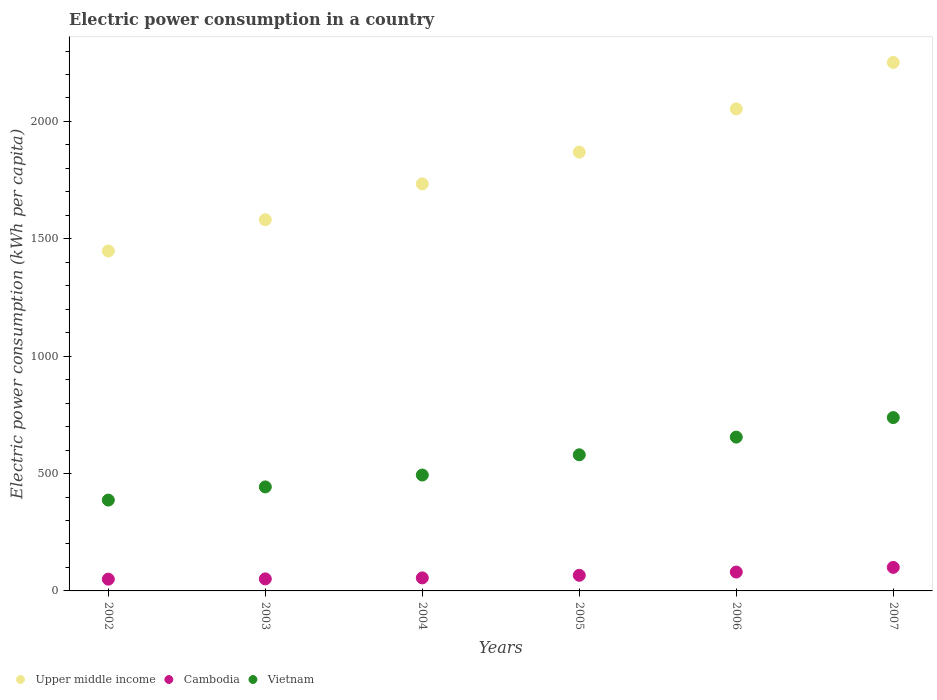How many different coloured dotlines are there?
Your answer should be compact. 3. What is the electric power consumption in in Cambodia in 2006?
Keep it short and to the point. 80.44. Across all years, what is the maximum electric power consumption in in Cambodia?
Offer a very short reply. 100.23. Across all years, what is the minimum electric power consumption in in Cambodia?
Your answer should be very brief. 50.15. In which year was the electric power consumption in in Vietnam maximum?
Provide a succinct answer. 2007. What is the total electric power consumption in in Cambodia in the graph?
Keep it short and to the point. 404.17. What is the difference between the electric power consumption in in Vietnam in 2003 and that in 2006?
Offer a very short reply. -212.25. What is the difference between the electric power consumption in in Cambodia in 2002 and the electric power consumption in in Upper middle income in 2005?
Ensure brevity in your answer.  -1819.17. What is the average electric power consumption in in Cambodia per year?
Offer a terse response. 67.36. In the year 2006, what is the difference between the electric power consumption in in Cambodia and electric power consumption in in Vietnam?
Ensure brevity in your answer.  -574.88. In how many years, is the electric power consumption in in Cambodia greater than 500 kWh per capita?
Make the answer very short. 0. What is the ratio of the electric power consumption in in Vietnam in 2005 to that in 2007?
Keep it short and to the point. 0.79. What is the difference between the highest and the second highest electric power consumption in in Vietnam?
Your answer should be compact. 83.15. What is the difference between the highest and the lowest electric power consumption in in Upper middle income?
Your response must be concise. 803.33. Is the sum of the electric power consumption in in Upper middle income in 2003 and 2004 greater than the maximum electric power consumption in in Cambodia across all years?
Give a very brief answer. Yes. Is it the case that in every year, the sum of the electric power consumption in in Upper middle income and electric power consumption in in Vietnam  is greater than the electric power consumption in in Cambodia?
Offer a very short reply. Yes. Is the electric power consumption in in Upper middle income strictly greater than the electric power consumption in in Cambodia over the years?
Offer a very short reply. Yes. How many years are there in the graph?
Your answer should be compact. 6. What is the difference between two consecutive major ticks on the Y-axis?
Provide a succinct answer. 500. Where does the legend appear in the graph?
Your response must be concise. Bottom left. How many legend labels are there?
Provide a succinct answer. 3. What is the title of the graph?
Keep it short and to the point. Electric power consumption in a country. Does "Moldova" appear as one of the legend labels in the graph?
Your answer should be very brief. No. What is the label or title of the X-axis?
Make the answer very short. Years. What is the label or title of the Y-axis?
Ensure brevity in your answer.  Electric power consumption (kWh per capita). What is the Electric power consumption (kWh per capita) in Upper middle income in 2002?
Ensure brevity in your answer.  1448.2. What is the Electric power consumption (kWh per capita) of Cambodia in 2002?
Your answer should be compact. 50.15. What is the Electric power consumption (kWh per capita) of Vietnam in 2002?
Your answer should be very brief. 387.04. What is the Electric power consumption (kWh per capita) in Upper middle income in 2003?
Make the answer very short. 1581.37. What is the Electric power consumption (kWh per capita) in Cambodia in 2003?
Provide a short and direct response. 51.31. What is the Electric power consumption (kWh per capita) in Vietnam in 2003?
Provide a succinct answer. 443.07. What is the Electric power consumption (kWh per capita) of Upper middle income in 2004?
Your answer should be very brief. 1734. What is the Electric power consumption (kWh per capita) of Cambodia in 2004?
Provide a succinct answer. 55.52. What is the Electric power consumption (kWh per capita) of Vietnam in 2004?
Provide a short and direct response. 493.62. What is the Electric power consumption (kWh per capita) in Upper middle income in 2005?
Your answer should be very brief. 1869.32. What is the Electric power consumption (kWh per capita) in Cambodia in 2005?
Provide a succinct answer. 66.52. What is the Electric power consumption (kWh per capita) in Vietnam in 2005?
Offer a very short reply. 579.92. What is the Electric power consumption (kWh per capita) in Upper middle income in 2006?
Provide a short and direct response. 2053.57. What is the Electric power consumption (kWh per capita) in Cambodia in 2006?
Your answer should be compact. 80.44. What is the Electric power consumption (kWh per capita) in Vietnam in 2006?
Provide a succinct answer. 655.33. What is the Electric power consumption (kWh per capita) in Upper middle income in 2007?
Your response must be concise. 2251.53. What is the Electric power consumption (kWh per capita) in Cambodia in 2007?
Provide a succinct answer. 100.23. What is the Electric power consumption (kWh per capita) in Vietnam in 2007?
Offer a terse response. 738.47. Across all years, what is the maximum Electric power consumption (kWh per capita) in Upper middle income?
Give a very brief answer. 2251.53. Across all years, what is the maximum Electric power consumption (kWh per capita) of Cambodia?
Provide a succinct answer. 100.23. Across all years, what is the maximum Electric power consumption (kWh per capita) in Vietnam?
Your answer should be compact. 738.47. Across all years, what is the minimum Electric power consumption (kWh per capita) of Upper middle income?
Offer a very short reply. 1448.2. Across all years, what is the minimum Electric power consumption (kWh per capita) in Cambodia?
Your response must be concise. 50.15. Across all years, what is the minimum Electric power consumption (kWh per capita) of Vietnam?
Your response must be concise. 387.04. What is the total Electric power consumption (kWh per capita) of Upper middle income in the graph?
Your answer should be compact. 1.09e+04. What is the total Electric power consumption (kWh per capita) of Cambodia in the graph?
Ensure brevity in your answer.  404.17. What is the total Electric power consumption (kWh per capita) of Vietnam in the graph?
Give a very brief answer. 3297.45. What is the difference between the Electric power consumption (kWh per capita) of Upper middle income in 2002 and that in 2003?
Your answer should be very brief. -133.17. What is the difference between the Electric power consumption (kWh per capita) in Cambodia in 2002 and that in 2003?
Your answer should be compact. -1.16. What is the difference between the Electric power consumption (kWh per capita) in Vietnam in 2002 and that in 2003?
Provide a succinct answer. -56.04. What is the difference between the Electric power consumption (kWh per capita) of Upper middle income in 2002 and that in 2004?
Your response must be concise. -285.8. What is the difference between the Electric power consumption (kWh per capita) of Cambodia in 2002 and that in 2004?
Your answer should be compact. -5.37. What is the difference between the Electric power consumption (kWh per capita) in Vietnam in 2002 and that in 2004?
Give a very brief answer. -106.59. What is the difference between the Electric power consumption (kWh per capita) of Upper middle income in 2002 and that in 2005?
Provide a short and direct response. -421.12. What is the difference between the Electric power consumption (kWh per capita) in Cambodia in 2002 and that in 2005?
Ensure brevity in your answer.  -16.37. What is the difference between the Electric power consumption (kWh per capita) of Vietnam in 2002 and that in 2005?
Keep it short and to the point. -192.89. What is the difference between the Electric power consumption (kWh per capita) of Upper middle income in 2002 and that in 2006?
Keep it short and to the point. -605.37. What is the difference between the Electric power consumption (kWh per capita) in Cambodia in 2002 and that in 2006?
Make the answer very short. -30.29. What is the difference between the Electric power consumption (kWh per capita) in Vietnam in 2002 and that in 2006?
Offer a very short reply. -268.29. What is the difference between the Electric power consumption (kWh per capita) of Upper middle income in 2002 and that in 2007?
Offer a very short reply. -803.33. What is the difference between the Electric power consumption (kWh per capita) in Cambodia in 2002 and that in 2007?
Provide a succinct answer. -50.08. What is the difference between the Electric power consumption (kWh per capita) in Vietnam in 2002 and that in 2007?
Your response must be concise. -351.44. What is the difference between the Electric power consumption (kWh per capita) of Upper middle income in 2003 and that in 2004?
Make the answer very short. -152.64. What is the difference between the Electric power consumption (kWh per capita) of Cambodia in 2003 and that in 2004?
Give a very brief answer. -4.21. What is the difference between the Electric power consumption (kWh per capita) of Vietnam in 2003 and that in 2004?
Offer a very short reply. -50.55. What is the difference between the Electric power consumption (kWh per capita) of Upper middle income in 2003 and that in 2005?
Make the answer very short. -287.95. What is the difference between the Electric power consumption (kWh per capita) of Cambodia in 2003 and that in 2005?
Your answer should be very brief. -15.2. What is the difference between the Electric power consumption (kWh per capita) in Vietnam in 2003 and that in 2005?
Your response must be concise. -136.85. What is the difference between the Electric power consumption (kWh per capita) in Upper middle income in 2003 and that in 2006?
Offer a terse response. -472.2. What is the difference between the Electric power consumption (kWh per capita) of Cambodia in 2003 and that in 2006?
Offer a terse response. -29.13. What is the difference between the Electric power consumption (kWh per capita) of Vietnam in 2003 and that in 2006?
Your response must be concise. -212.25. What is the difference between the Electric power consumption (kWh per capita) of Upper middle income in 2003 and that in 2007?
Offer a very short reply. -670.17. What is the difference between the Electric power consumption (kWh per capita) of Cambodia in 2003 and that in 2007?
Give a very brief answer. -48.91. What is the difference between the Electric power consumption (kWh per capita) of Vietnam in 2003 and that in 2007?
Your response must be concise. -295.4. What is the difference between the Electric power consumption (kWh per capita) in Upper middle income in 2004 and that in 2005?
Your response must be concise. -135.32. What is the difference between the Electric power consumption (kWh per capita) of Cambodia in 2004 and that in 2005?
Make the answer very short. -11. What is the difference between the Electric power consumption (kWh per capita) of Vietnam in 2004 and that in 2005?
Provide a short and direct response. -86.3. What is the difference between the Electric power consumption (kWh per capita) in Upper middle income in 2004 and that in 2006?
Make the answer very short. -319.56. What is the difference between the Electric power consumption (kWh per capita) in Cambodia in 2004 and that in 2006?
Keep it short and to the point. -24.92. What is the difference between the Electric power consumption (kWh per capita) of Vietnam in 2004 and that in 2006?
Keep it short and to the point. -161.7. What is the difference between the Electric power consumption (kWh per capita) in Upper middle income in 2004 and that in 2007?
Offer a terse response. -517.53. What is the difference between the Electric power consumption (kWh per capita) of Cambodia in 2004 and that in 2007?
Provide a succinct answer. -44.71. What is the difference between the Electric power consumption (kWh per capita) of Vietnam in 2004 and that in 2007?
Provide a short and direct response. -244.85. What is the difference between the Electric power consumption (kWh per capita) of Upper middle income in 2005 and that in 2006?
Your response must be concise. -184.25. What is the difference between the Electric power consumption (kWh per capita) of Cambodia in 2005 and that in 2006?
Make the answer very short. -13.93. What is the difference between the Electric power consumption (kWh per capita) of Vietnam in 2005 and that in 2006?
Your response must be concise. -75.4. What is the difference between the Electric power consumption (kWh per capita) in Upper middle income in 2005 and that in 2007?
Your answer should be very brief. -382.21. What is the difference between the Electric power consumption (kWh per capita) in Cambodia in 2005 and that in 2007?
Ensure brevity in your answer.  -33.71. What is the difference between the Electric power consumption (kWh per capita) of Vietnam in 2005 and that in 2007?
Offer a terse response. -158.55. What is the difference between the Electric power consumption (kWh per capita) of Upper middle income in 2006 and that in 2007?
Offer a terse response. -197.97. What is the difference between the Electric power consumption (kWh per capita) of Cambodia in 2006 and that in 2007?
Ensure brevity in your answer.  -19.79. What is the difference between the Electric power consumption (kWh per capita) of Vietnam in 2006 and that in 2007?
Your response must be concise. -83.15. What is the difference between the Electric power consumption (kWh per capita) of Upper middle income in 2002 and the Electric power consumption (kWh per capita) of Cambodia in 2003?
Your answer should be compact. 1396.89. What is the difference between the Electric power consumption (kWh per capita) of Upper middle income in 2002 and the Electric power consumption (kWh per capita) of Vietnam in 2003?
Your answer should be very brief. 1005.13. What is the difference between the Electric power consumption (kWh per capita) of Cambodia in 2002 and the Electric power consumption (kWh per capita) of Vietnam in 2003?
Your answer should be compact. -392.92. What is the difference between the Electric power consumption (kWh per capita) in Upper middle income in 2002 and the Electric power consumption (kWh per capita) in Cambodia in 2004?
Ensure brevity in your answer.  1392.68. What is the difference between the Electric power consumption (kWh per capita) of Upper middle income in 2002 and the Electric power consumption (kWh per capita) of Vietnam in 2004?
Your answer should be compact. 954.58. What is the difference between the Electric power consumption (kWh per capita) in Cambodia in 2002 and the Electric power consumption (kWh per capita) in Vietnam in 2004?
Provide a succinct answer. -443.47. What is the difference between the Electric power consumption (kWh per capita) in Upper middle income in 2002 and the Electric power consumption (kWh per capita) in Cambodia in 2005?
Provide a succinct answer. 1381.68. What is the difference between the Electric power consumption (kWh per capita) of Upper middle income in 2002 and the Electric power consumption (kWh per capita) of Vietnam in 2005?
Your response must be concise. 868.28. What is the difference between the Electric power consumption (kWh per capita) of Cambodia in 2002 and the Electric power consumption (kWh per capita) of Vietnam in 2005?
Make the answer very short. -529.77. What is the difference between the Electric power consumption (kWh per capita) in Upper middle income in 2002 and the Electric power consumption (kWh per capita) in Cambodia in 2006?
Offer a very short reply. 1367.76. What is the difference between the Electric power consumption (kWh per capita) of Upper middle income in 2002 and the Electric power consumption (kWh per capita) of Vietnam in 2006?
Offer a very short reply. 792.87. What is the difference between the Electric power consumption (kWh per capita) of Cambodia in 2002 and the Electric power consumption (kWh per capita) of Vietnam in 2006?
Your response must be concise. -605.18. What is the difference between the Electric power consumption (kWh per capita) in Upper middle income in 2002 and the Electric power consumption (kWh per capita) in Cambodia in 2007?
Provide a short and direct response. 1347.97. What is the difference between the Electric power consumption (kWh per capita) of Upper middle income in 2002 and the Electric power consumption (kWh per capita) of Vietnam in 2007?
Give a very brief answer. 709.73. What is the difference between the Electric power consumption (kWh per capita) in Cambodia in 2002 and the Electric power consumption (kWh per capita) in Vietnam in 2007?
Offer a very short reply. -688.32. What is the difference between the Electric power consumption (kWh per capita) in Upper middle income in 2003 and the Electric power consumption (kWh per capita) in Cambodia in 2004?
Make the answer very short. 1525.85. What is the difference between the Electric power consumption (kWh per capita) of Upper middle income in 2003 and the Electric power consumption (kWh per capita) of Vietnam in 2004?
Your answer should be very brief. 1087.74. What is the difference between the Electric power consumption (kWh per capita) in Cambodia in 2003 and the Electric power consumption (kWh per capita) in Vietnam in 2004?
Offer a terse response. -442.31. What is the difference between the Electric power consumption (kWh per capita) in Upper middle income in 2003 and the Electric power consumption (kWh per capita) in Cambodia in 2005?
Keep it short and to the point. 1514.85. What is the difference between the Electric power consumption (kWh per capita) of Upper middle income in 2003 and the Electric power consumption (kWh per capita) of Vietnam in 2005?
Provide a short and direct response. 1001.45. What is the difference between the Electric power consumption (kWh per capita) in Cambodia in 2003 and the Electric power consumption (kWh per capita) in Vietnam in 2005?
Give a very brief answer. -528.61. What is the difference between the Electric power consumption (kWh per capita) of Upper middle income in 2003 and the Electric power consumption (kWh per capita) of Cambodia in 2006?
Provide a short and direct response. 1500.93. What is the difference between the Electric power consumption (kWh per capita) of Upper middle income in 2003 and the Electric power consumption (kWh per capita) of Vietnam in 2006?
Offer a very short reply. 926.04. What is the difference between the Electric power consumption (kWh per capita) of Cambodia in 2003 and the Electric power consumption (kWh per capita) of Vietnam in 2006?
Ensure brevity in your answer.  -604.01. What is the difference between the Electric power consumption (kWh per capita) in Upper middle income in 2003 and the Electric power consumption (kWh per capita) in Cambodia in 2007?
Your answer should be compact. 1481.14. What is the difference between the Electric power consumption (kWh per capita) of Upper middle income in 2003 and the Electric power consumption (kWh per capita) of Vietnam in 2007?
Your answer should be very brief. 842.9. What is the difference between the Electric power consumption (kWh per capita) of Cambodia in 2003 and the Electric power consumption (kWh per capita) of Vietnam in 2007?
Offer a very short reply. -687.16. What is the difference between the Electric power consumption (kWh per capita) in Upper middle income in 2004 and the Electric power consumption (kWh per capita) in Cambodia in 2005?
Offer a terse response. 1667.49. What is the difference between the Electric power consumption (kWh per capita) in Upper middle income in 2004 and the Electric power consumption (kWh per capita) in Vietnam in 2005?
Your response must be concise. 1154.08. What is the difference between the Electric power consumption (kWh per capita) of Cambodia in 2004 and the Electric power consumption (kWh per capita) of Vietnam in 2005?
Provide a succinct answer. -524.4. What is the difference between the Electric power consumption (kWh per capita) of Upper middle income in 2004 and the Electric power consumption (kWh per capita) of Cambodia in 2006?
Offer a terse response. 1653.56. What is the difference between the Electric power consumption (kWh per capita) in Upper middle income in 2004 and the Electric power consumption (kWh per capita) in Vietnam in 2006?
Offer a very short reply. 1078.68. What is the difference between the Electric power consumption (kWh per capita) of Cambodia in 2004 and the Electric power consumption (kWh per capita) of Vietnam in 2006?
Give a very brief answer. -599.81. What is the difference between the Electric power consumption (kWh per capita) in Upper middle income in 2004 and the Electric power consumption (kWh per capita) in Cambodia in 2007?
Provide a succinct answer. 1633.78. What is the difference between the Electric power consumption (kWh per capita) in Upper middle income in 2004 and the Electric power consumption (kWh per capita) in Vietnam in 2007?
Make the answer very short. 995.53. What is the difference between the Electric power consumption (kWh per capita) of Cambodia in 2004 and the Electric power consumption (kWh per capita) of Vietnam in 2007?
Give a very brief answer. -682.95. What is the difference between the Electric power consumption (kWh per capita) of Upper middle income in 2005 and the Electric power consumption (kWh per capita) of Cambodia in 2006?
Offer a very short reply. 1788.88. What is the difference between the Electric power consumption (kWh per capita) in Upper middle income in 2005 and the Electric power consumption (kWh per capita) in Vietnam in 2006?
Your answer should be compact. 1214. What is the difference between the Electric power consumption (kWh per capita) in Cambodia in 2005 and the Electric power consumption (kWh per capita) in Vietnam in 2006?
Ensure brevity in your answer.  -588.81. What is the difference between the Electric power consumption (kWh per capita) in Upper middle income in 2005 and the Electric power consumption (kWh per capita) in Cambodia in 2007?
Provide a succinct answer. 1769.09. What is the difference between the Electric power consumption (kWh per capita) in Upper middle income in 2005 and the Electric power consumption (kWh per capita) in Vietnam in 2007?
Ensure brevity in your answer.  1130.85. What is the difference between the Electric power consumption (kWh per capita) of Cambodia in 2005 and the Electric power consumption (kWh per capita) of Vietnam in 2007?
Keep it short and to the point. -671.96. What is the difference between the Electric power consumption (kWh per capita) of Upper middle income in 2006 and the Electric power consumption (kWh per capita) of Cambodia in 2007?
Keep it short and to the point. 1953.34. What is the difference between the Electric power consumption (kWh per capita) of Upper middle income in 2006 and the Electric power consumption (kWh per capita) of Vietnam in 2007?
Your answer should be compact. 1315.1. What is the difference between the Electric power consumption (kWh per capita) in Cambodia in 2006 and the Electric power consumption (kWh per capita) in Vietnam in 2007?
Offer a terse response. -658.03. What is the average Electric power consumption (kWh per capita) of Upper middle income per year?
Give a very brief answer. 1823. What is the average Electric power consumption (kWh per capita) in Cambodia per year?
Keep it short and to the point. 67.36. What is the average Electric power consumption (kWh per capita) of Vietnam per year?
Ensure brevity in your answer.  549.58. In the year 2002, what is the difference between the Electric power consumption (kWh per capita) in Upper middle income and Electric power consumption (kWh per capita) in Cambodia?
Offer a terse response. 1398.05. In the year 2002, what is the difference between the Electric power consumption (kWh per capita) of Upper middle income and Electric power consumption (kWh per capita) of Vietnam?
Provide a succinct answer. 1061.16. In the year 2002, what is the difference between the Electric power consumption (kWh per capita) of Cambodia and Electric power consumption (kWh per capita) of Vietnam?
Provide a short and direct response. -336.89. In the year 2003, what is the difference between the Electric power consumption (kWh per capita) in Upper middle income and Electric power consumption (kWh per capita) in Cambodia?
Your response must be concise. 1530.05. In the year 2003, what is the difference between the Electric power consumption (kWh per capita) of Upper middle income and Electric power consumption (kWh per capita) of Vietnam?
Provide a succinct answer. 1138.29. In the year 2003, what is the difference between the Electric power consumption (kWh per capita) in Cambodia and Electric power consumption (kWh per capita) in Vietnam?
Ensure brevity in your answer.  -391.76. In the year 2004, what is the difference between the Electric power consumption (kWh per capita) of Upper middle income and Electric power consumption (kWh per capita) of Cambodia?
Keep it short and to the point. 1678.48. In the year 2004, what is the difference between the Electric power consumption (kWh per capita) of Upper middle income and Electric power consumption (kWh per capita) of Vietnam?
Your response must be concise. 1240.38. In the year 2004, what is the difference between the Electric power consumption (kWh per capita) of Cambodia and Electric power consumption (kWh per capita) of Vietnam?
Provide a succinct answer. -438.1. In the year 2005, what is the difference between the Electric power consumption (kWh per capita) of Upper middle income and Electric power consumption (kWh per capita) of Cambodia?
Offer a very short reply. 1802.81. In the year 2005, what is the difference between the Electric power consumption (kWh per capita) of Upper middle income and Electric power consumption (kWh per capita) of Vietnam?
Your answer should be compact. 1289.4. In the year 2005, what is the difference between the Electric power consumption (kWh per capita) in Cambodia and Electric power consumption (kWh per capita) in Vietnam?
Your answer should be compact. -513.41. In the year 2006, what is the difference between the Electric power consumption (kWh per capita) of Upper middle income and Electric power consumption (kWh per capita) of Cambodia?
Your answer should be very brief. 1973.13. In the year 2006, what is the difference between the Electric power consumption (kWh per capita) of Upper middle income and Electric power consumption (kWh per capita) of Vietnam?
Offer a very short reply. 1398.24. In the year 2006, what is the difference between the Electric power consumption (kWh per capita) of Cambodia and Electric power consumption (kWh per capita) of Vietnam?
Make the answer very short. -574.88. In the year 2007, what is the difference between the Electric power consumption (kWh per capita) in Upper middle income and Electric power consumption (kWh per capita) in Cambodia?
Provide a succinct answer. 2151.31. In the year 2007, what is the difference between the Electric power consumption (kWh per capita) in Upper middle income and Electric power consumption (kWh per capita) in Vietnam?
Your answer should be very brief. 1513.06. In the year 2007, what is the difference between the Electric power consumption (kWh per capita) of Cambodia and Electric power consumption (kWh per capita) of Vietnam?
Your answer should be very brief. -638.24. What is the ratio of the Electric power consumption (kWh per capita) in Upper middle income in 2002 to that in 2003?
Offer a terse response. 0.92. What is the ratio of the Electric power consumption (kWh per capita) of Cambodia in 2002 to that in 2003?
Provide a short and direct response. 0.98. What is the ratio of the Electric power consumption (kWh per capita) in Vietnam in 2002 to that in 2003?
Keep it short and to the point. 0.87. What is the ratio of the Electric power consumption (kWh per capita) of Upper middle income in 2002 to that in 2004?
Offer a very short reply. 0.84. What is the ratio of the Electric power consumption (kWh per capita) of Cambodia in 2002 to that in 2004?
Provide a succinct answer. 0.9. What is the ratio of the Electric power consumption (kWh per capita) of Vietnam in 2002 to that in 2004?
Give a very brief answer. 0.78. What is the ratio of the Electric power consumption (kWh per capita) of Upper middle income in 2002 to that in 2005?
Your answer should be very brief. 0.77. What is the ratio of the Electric power consumption (kWh per capita) in Cambodia in 2002 to that in 2005?
Give a very brief answer. 0.75. What is the ratio of the Electric power consumption (kWh per capita) of Vietnam in 2002 to that in 2005?
Provide a short and direct response. 0.67. What is the ratio of the Electric power consumption (kWh per capita) in Upper middle income in 2002 to that in 2006?
Give a very brief answer. 0.71. What is the ratio of the Electric power consumption (kWh per capita) in Cambodia in 2002 to that in 2006?
Your answer should be very brief. 0.62. What is the ratio of the Electric power consumption (kWh per capita) in Vietnam in 2002 to that in 2006?
Provide a succinct answer. 0.59. What is the ratio of the Electric power consumption (kWh per capita) in Upper middle income in 2002 to that in 2007?
Your answer should be compact. 0.64. What is the ratio of the Electric power consumption (kWh per capita) of Cambodia in 2002 to that in 2007?
Offer a terse response. 0.5. What is the ratio of the Electric power consumption (kWh per capita) of Vietnam in 2002 to that in 2007?
Keep it short and to the point. 0.52. What is the ratio of the Electric power consumption (kWh per capita) of Upper middle income in 2003 to that in 2004?
Make the answer very short. 0.91. What is the ratio of the Electric power consumption (kWh per capita) of Cambodia in 2003 to that in 2004?
Provide a succinct answer. 0.92. What is the ratio of the Electric power consumption (kWh per capita) in Vietnam in 2003 to that in 2004?
Provide a short and direct response. 0.9. What is the ratio of the Electric power consumption (kWh per capita) of Upper middle income in 2003 to that in 2005?
Provide a succinct answer. 0.85. What is the ratio of the Electric power consumption (kWh per capita) of Cambodia in 2003 to that in 2005?
Your answer should be compact. 0.77. What is the ratio of the Electric power consumption (kWh per capita) of Vietnam in 2003 to that in 2005?
Provide a short and direct response. 0.76. What is the ratio of the Electric power consumption (kWh per capita) of Upper middle income in 2003 to that in 2006?
Keep it short and to the point. 0.77. What is the ratio of the Electric power consumption (kWh per capita) in Cambodia in 2003 to that in 2006?
Give a very brief answer. 0.64. What is the ratio of the Electric power consumption (kWh per capita) in Vietnam in 2003 to that in 2006?
Ensure brevity in your answer.  0.68. What is the ratio of the Electric power consumption (kWh per capita) of Upper middle income in 2003 to that in 2007?
Provide a short and direct response. 0.7. What is the ratio of the Electric power consumption (kWh per capita) in Cambodia in 2003 to that in 2007?
Your response must be concise. 0.51. What is the ratio of the Electric power consumption (kWh per capita) of Upper middle income in 2004 to that in 2005?
Your answer should be compact. 0.93. What is the ratio of the Electric power consumption (kWh per capita) in Cambodia in 2004 to that in 2005?
Your answer should be compact. 0.83. What is the ratio of the Electric power consumption (kWh per capita) of Vietnam in 2004 to that in 2005?
Provide a succinct answer. 0.85. What is the ratio of the Electric power consumption (kWh per capita) of Upper middle income in 2004 to that in 2006?
Provide a short and direct response. 0.84. What is the ratio of the Electric power consumption (kWh per capita) in Cambodia in 2004 to that in 2006?
Keep it short and to the point. 0.69. What is the ratio of the Electric power consumption (kWh per capita) of Vietnam in 2004 to that in 2006?
Your response must be concise. 0.75. What is the ratio of the Electric power consumption (kWh per capita) of Upper middle income in 2004 to that in 2007?
Offer a terse response. 0.77. What is the ratio of the Electric power consumption (kWh per capita) in Cambodia in 2004 to that in 2007?
Make the answer very short. 0.55. What is the ratio of the Electric power consumption (kWh per capita) in Vietnam in 2004 to that in 2007?
Your answer should be very brief. 0.67. What is the ratio of the Electric power consumption (kWh per capita) of Upper middle income in 2005 to that in 2006?
Provide a short and direct response. 0.91. What is the ratio of the Electric power consumption (kWh per capita) of Cambodia in 2005 to that in 2006?
Keep it short and to the point. 0.83. What is the ratio of the Electric power consumption (kWh per capita) of Vietnam in 2005 to that in 2006?
Keep it short and to the point. 0.88. What is the ratio of the Electric power consumption (kWh per capita) in Upper middle income in 2005 to that in 2007?
Your answer should be compact. 0.83. What is the ratio of the Electric power consumption (kWh per capita) in Cambodia in 2005 to that in 2007?
Make the answer very short. 0.66. What is the ratio of the Electric power consumption (kWh per capita) of Vietnam in 2005 to that in 2007?
Keep it short and to the point. 0.79. What is the ratio of the Electric power consumption (kWh per capita) in Upper middle income in 2006 to that in 2007?
Your answer should be compact. 0.91. What is the ratio of the Electric power consumption (kWh per capita) in Cambodia in 2006 to that in 2007?
Offer a very short reply. 0.8. What is the ratio of the Electric power consumption (kWh per capita) of Vietnam in 2006 to that in 2007?
Provide a short and direct response. 0.89. What is the difference between the highest and the second highest Electric power consumption (kWh per capita) in Upper middle income?
Your answer should be compact. 197.97. What is the difference between the highest and the second highest Electric power consumption (kWh per capita) of Cambodia?
Your response must be concise. 19.79. What is the difference between the highest and the second highest Electric power consumption (kWh per capita) of Vietnam?
Your answer should be compact. 83.15. What is the difference between the highest and the lowest Electric power consumption (kWh per capita) of Upper middle income?
Your answer should be very brief. 803.33. What is the difference between the highest and the lowest Electric power consumption (kWh per capita) in Cambodia?
Provide a succinct answer. 50.08. What is the difference between the highest and the lowest Electric power consumption (kWh per capita) of Vietnam?
Ensure brevity in your answer.  351.44. 